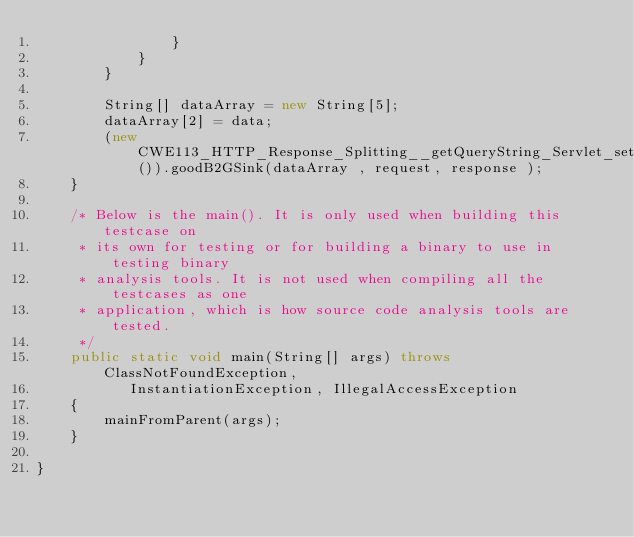Convert code to text. <code><loc_0><loc_0><loc_500><loc_500><_Java_>                }
            }
        }

        String[] dataArray = new String[5];
        dataArray[2] = data;
        (new CWE113_HTTP_Response_Splitting__getQueryString_Servlet_setHeaderServlet_66b()).goodB2GSink(dataArray , request, response );
    }

    /* Below is the main(). It is only used when building this testcase on
     * its own for testing or for building a binary to use in testing binary
     * analysis tools. It is not used when compiling all the testcases as one
     * application, which is how source code analysis tools are tested.
     */
    public static void main(String[] args) throws ClassNotFoundException,
           InstantiationException, IllegalAccessException
    {
        mainFromParent(args);
    }

}
</code> 